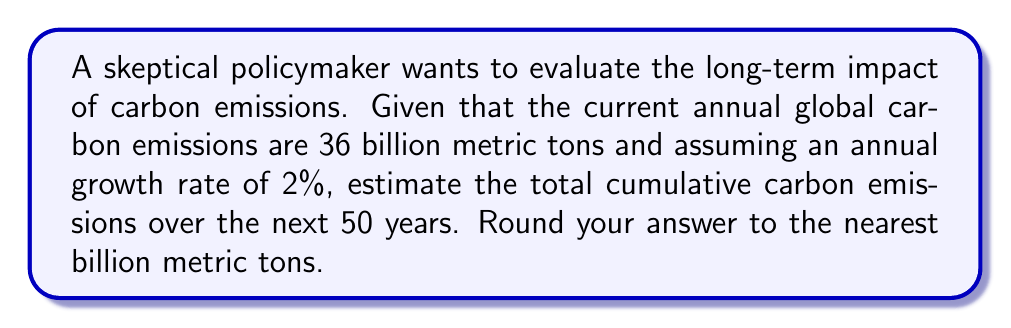What is the answer to this math problem? To solve this problem, we'll use the exponential growth model and the formula for the sum of a geometric series.

Step 1: Set up the exponential growth model
Let $A(t)$ be the annual emissions after $t$ years.
$A(t) = A_0(1+r)^t$, where $A_0 = 36$ billion tons and $r = 0.02$

Step 2: Calculate the sum of emissions over 50 years
We need to find $\sum_{t=0}^{49} A(t)$

This is a geometric series with first term $a = 36$ and common ratio $q = 1.02$

The sum of a geometric series is given by:
$S_n = \frac{a(1-q^n)}{1-q}$, where $n = 50$

Step 3: Apply the formula
$$S_{50} = \frac{36(1-1.02^{50})}{1-1.02}$$

Step 4: Calculate
$$S_{50} = \frac{36(1-2.6916)}{-0.02} = \frac{36(-1.6916)}{-0.02} = 3044.88$$

Step 5: Round to the nearest billion
3045 billion metric tons
Answer: 3045 billion metric tons 